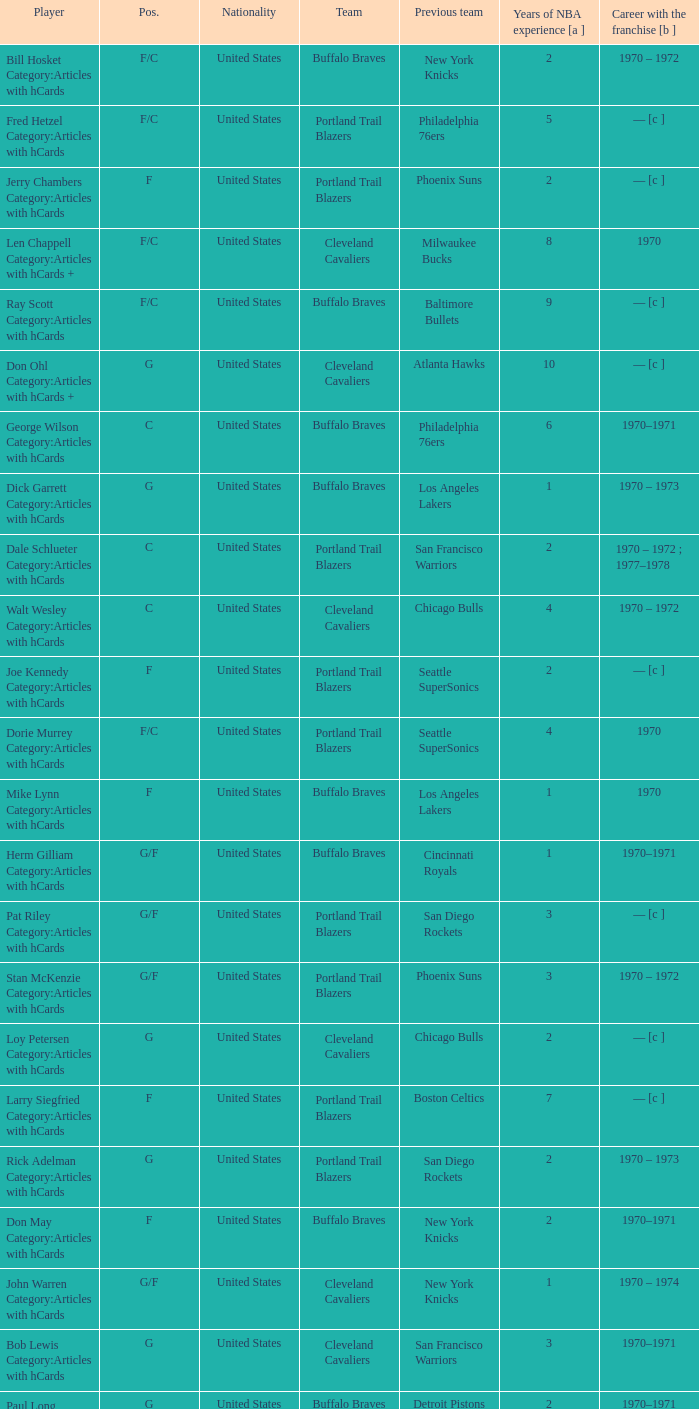How many years of NBA experience does the player who plays position g for the Portland Trail Blazers? 2.0. 